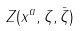Convert formula to latex. <formula><loc_0><loc_0><loc_500><loc_500>Z ( x ^ { a } , \zeta , \bar { \zeta } )</formula> 